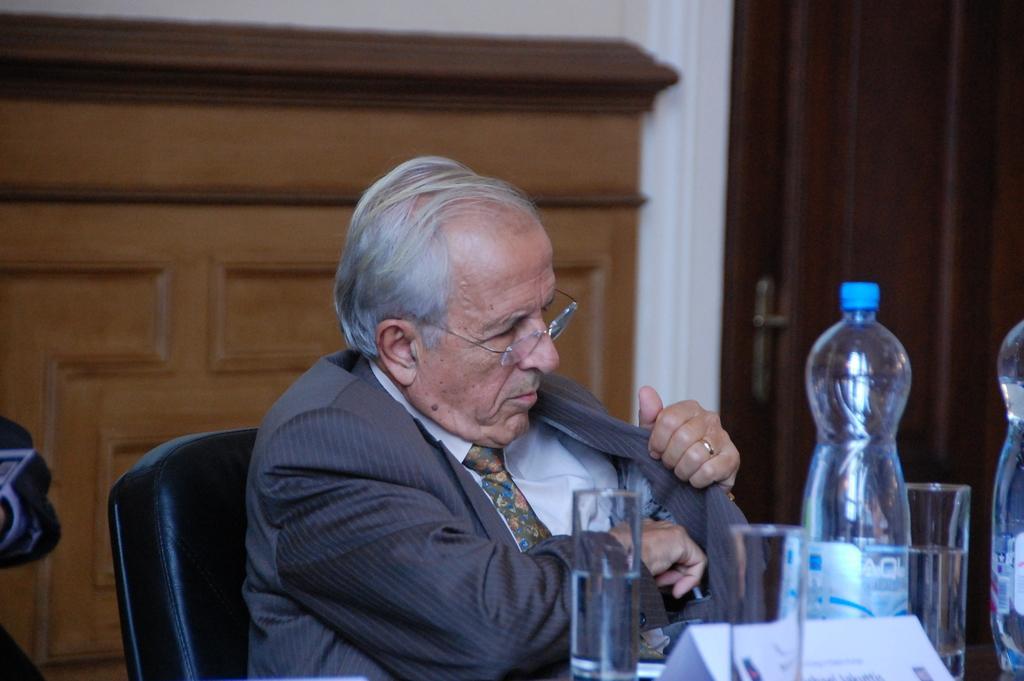Could you give a brief overview of what you see in this image? In this image i can see a man sitting on a chair there is a bottle, two glasses in front of him at the back ground a cup board and a wall. 